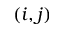<formula> <loc_0><loc_0><loc_500><loc_500>( i , j )</formula> 